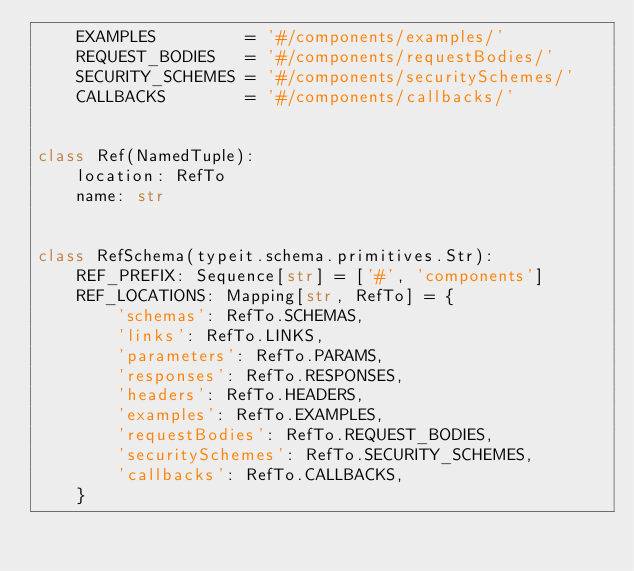<code> <loc_0><loc_0><loc_500><loc_500><_Python_>    EXAMPLES         = '#/components/examples/'
    REQUEST_BODIES   = '#/components/requestBodies/'
    SECURITY_SCHEMES = '#/components/securitySchemes/'
    CALLBACKS        = '#/components/callbacks/'


class Ref(NamedTuple):
    location: RefTo
    name: str


class RefSchema(typeit.schema.primitives.Str):
    REF_PREFIX: Sequence[str] = ['#', 'components']
    REF_LOCATIONS: Mapping[str, RefTo] = {
        'schemas': RefTo.SCHEMAS,
        'links': RefTo.LINKS,
        'parameters': RefTo.PARAMS,
        'responses': RefTo.RESPONSES,
        'headers': RefTo.HEADERS,
        'examples': RefTo.EXAMPLES,
        'requestBodies': RefTo.REQUEST_BODIES,
        'securitySchemes': RefTo.SECURITY_SCHEMES,
        'callbacks': RefTo.CALLBACKS,
    }
</code> 